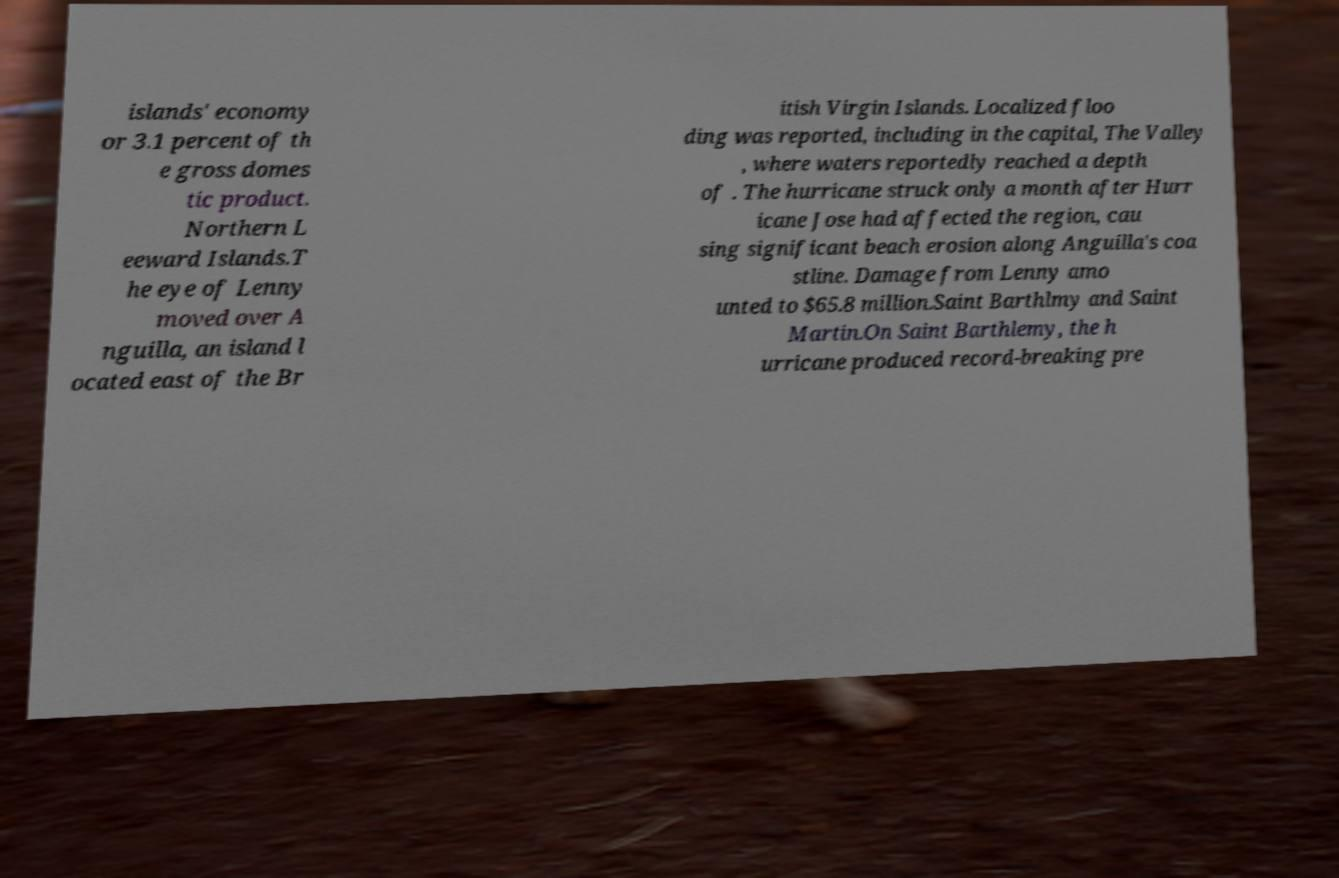Can you read and provide the text displayed in the image?This photo seems to have some interesting text. Can you extract and type it out for me? islands' economy or 3.1 percent of th e gross domes tic product. Northern L eeward Islands.T he eye of Lenny moved over A nguilla, an island l ocated east of the Br itish Virgin Islands. Localized floo ding was reported, including in the capital, The Valley , where waters reportedly reached a depth of . The hurricane struck only a month after Hurr icane Jose had affected the region, cau sing significant beach erosion along Anguilla's coa stline. Damage from Lenny amo unted to $65.8 million.Saint Barthlmy and Saint Martin.On Saint Barthlemy, the h urricane produced record-breaking pre 